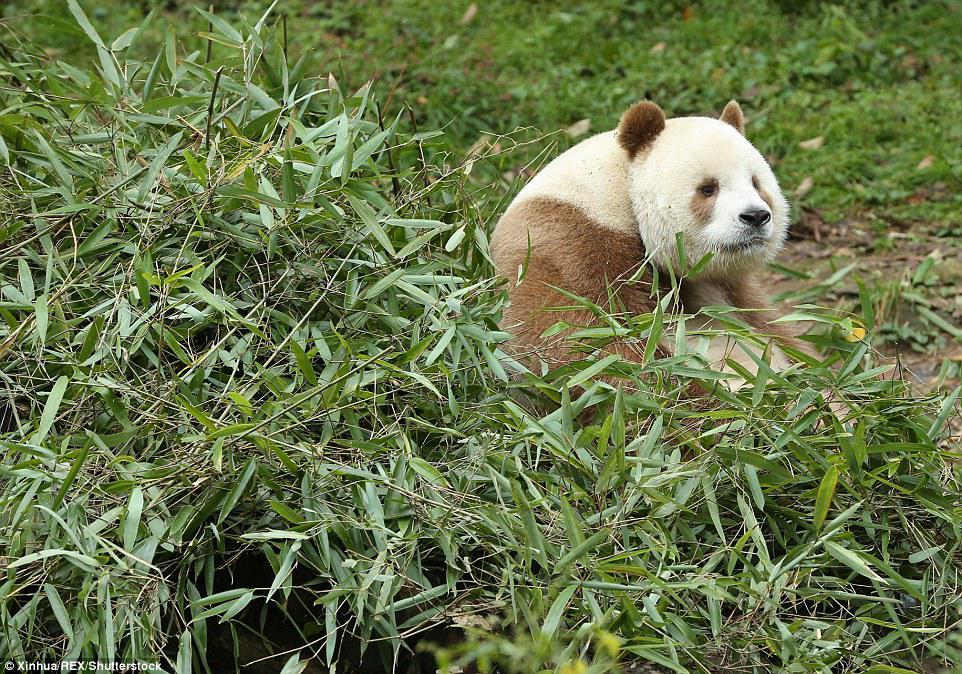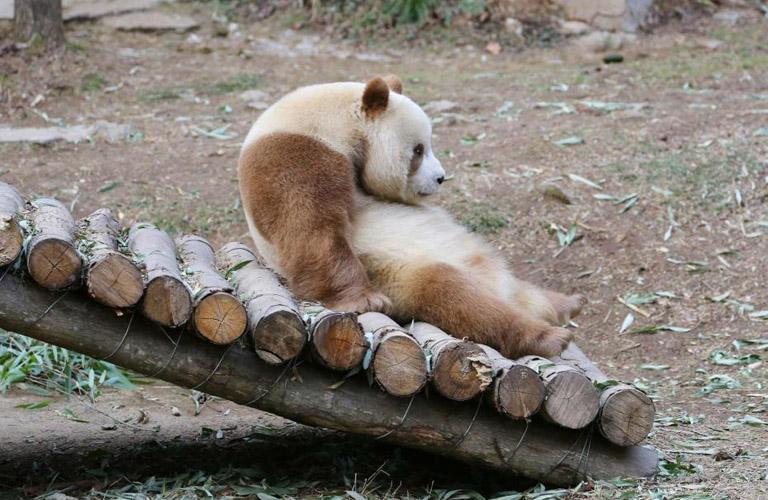The first image is the image on the left, the second image is the image on the right. Analyze the images presented: Is the assertion "Right image shows a panda half sitting, half lying, with legs extended and back curled." valid? Answer yes or no. Yes. The first image is the image on the left, the second image is the image on the right. For the images shown, is this caption "A panda is feeding itself." true? Answer yes or no. No. 